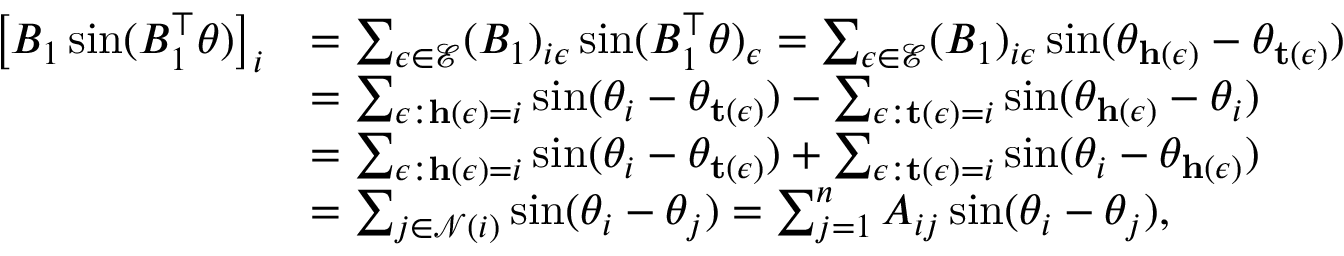Convert formula to latex. <formula><loc_0><loc_0><loc_500><loc_500>\begin{array} { r l } { \left [ B _ { 1 } \sin ( B _ { 1 } ^ { \top } \theta ) \right ] _ { i } } & { = \sum _ { \epsilon \in \mathcal { E } } ( B _ { 1 } ) _ { i \epsilon } \sin ( B _ { 1 } ^ { \top } \theta ) _ { \epsilon } = \sum _ { \epsilon \in \mathcal { E } } ( B _ { 1 } ) _ { i \epsilon } \sin ( \theta _ { h ( \epsilon ) } - \theta _ { t ( \epsilon ) } ) } \\ & { = \sum _ { \epsilon \colon h ( \epsilon ) = i } \sin ( \theta _ { i } - \theta _ { t ( \epsilon ) } ) - \sum _ { \epsilon \colon t ( \epsilon ) = i } \sin ( \theta _ { h ( \epsilon ) } - \theta _ { i } ) } \\ & { = \sum _ { \epsilon \colon h ( \epsilon ) = i } \sin ( \theta _ { i } - \theta _ { t ( \epsilon ) } ) + \sum _ { \epsilon \colon t ( \epsilon ) = i } \sin ( \theta _ { i } - \theta _ { h ( \epsilon ) } ) } \\ & { = \sum _ { j \in \mathcal { N } ( i ) } \sin ( \theta _ { i } - \theta _ { j } ) = \sum _ { j = 1 } ^ { n } A _ { i j } \sin ( \theta _ { i } - \theta _ { j } ) , } \end{array}</formula> 